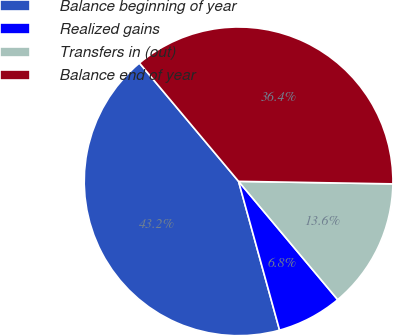Convert chart. <chart><loc_0><loc_0><loc_500><loc_500><pie_chart><fcel>Balance beginning of year<fcel>Realized gains<fcel>Transfers in (out)<fcel>Balance end of year<nl><fcel>43.18%<fcel>6.82%<fcel>13.64%<fcel>36.36%<nl></chart> 